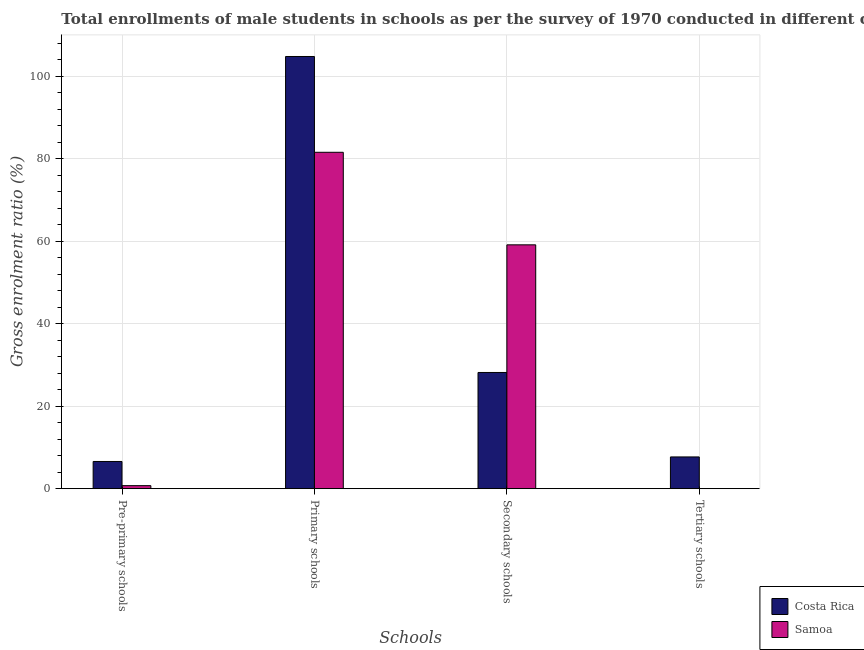How many different coloured bars are there?
Your answer should be compact. 2. How many groups of bars are there?
Your answer should be very brief. 4. Are the number of bars per tick equal to the number of legend labels?
Your response must be concise. Yes. Are the number of bars on each tick of the X-axis equal?
Your answer should be very brief. Yes. What is the label of the 3rd group of bars from the left?
Provide a succinct answer. Secondary schools. What is the gross enrolment ratio(male) in tertiary schools in Samoa?
Ensure brevity in your answer.  0.02. Across all countries, what is the maximum gross enrolment ratio(male) in pre-primary schools?
Ensure brevity in your answer.  6.6. Across all countries, what is the minimum gross enrolment ratio(male) in primary schools?
Keep it short and to the point. 81.57. In which country was the gross enrolment ratio(male) in secondary schools maximum?
Make the answer very short. Samoa. What is the total gross enrolment ratio(male) in pre-primary schools in the graph?
Provide a short and direct response. 7.33. What is the difference between the gross enrolment ratio(male) in tertiary schools in Samoa and that in Costa Rica?
Offer a terse response. -7.68. What is the difference between the gross enrolment ratio(male) in primary schools in Samoa and the gross enrolment ratio(male) in secondary schools in Costa Rica?
Your answer should be very brief. 53.39. What is the average gross enrolment ratio(male) in secondary schools per country?
Make the answer very short. 43.65. What is the difference between the gross enrolment ratio(male) in secondary schools and gross enrolment ratio(male) in primary schools in Samoa?
Make the answer very short. -22.44. In how many countries, is the gross enrolment ratio(male) in primary schools greater than 12 %?
Keep it short and to the point. 2. What is the ratio of the gross enrolment ratio(male) in pre-primary schools in Costa Rica to that in Samoa?
Provide a short and direct response. 8.98. Is the difference between the gross enrolment ratio(male) in primary schools in Costa Rica and Samoa greater than the difference between the gross enrolment ratio(male) in secondary schools in Costa Rica and Samoa?
Offer a terse response. Yes. What is the difference between the highest and the second highest gross enrolment ratio(male) in primary schools?
Keep it short and to the point. 23.23. What is the difference between the highest and the lowest gross enrolment ratio(male) in primary schools?
Your answer should be very brief. 23.23. In how many countries, is the gross enrolment ratio(male) in primary schools greater than the average gross enrolment ratio(male) in primary schools taken over all countries?
Offer a terse response. 1. Is the sum of the gross enrolment ratio(male) in tertiary schools in Samoa and Costa Rica greater than the maximum gross enrolment ratio(male) in secondary schools across all countries?
Provide a succinct answer. No. What does the 1st bar from the right in Tertiary schools represents?
Offer a terse response. Samoa. Are all the bars in the graph horizontal?
Ensure brevity in your answer.  No. What is the difference between two consecutive major ticks on the Y-axis?
Ensure brevity in your answer.  20. Does the graph contain any zero values?
Keep it short and to the point. No. Where does the legend appear in the graph?
Provide a short and direct response. Bottom right. How many legend labels are there?
Offer a very short reply. 2. What is the title of the graph?
Provide a succinct answer. Total enrollments of male students in schools as per the survey of 1970 conducted in different countries. What is the label or title of the X-axis?
Ensure brevity in your answer.  Schools. What is the label or title of the Y-axis?
Offer a terse response. Gross enrolment ratio (%). What is the Gross enrolment ratio (%) of Costa Rica in Pre-primary schools?
Give a very brief answer. 6.6. What is the Gross enrolment ratio (%) in Samoa in Pre-primary schools?
Give a very brief answer. 0.73. What is the Gross enrolment ratio (%) of Costa Rica in Primary schools?
Your response must be concise. 104.8. What is the Gross enrolment ratio (%) in Samoa in Primary schools?
Provide a short and direct response. 81.57. What is the Gross enrolment ratio (%) in Costa Rica in Secondary schools?
Keep it short and to the point. 28.18. What is the Gross enrolment ratio (%) in Samoa in Secondary schools?
Make the answer very short. 59.13. What is the Gross enrolment ratio (%) of Costa Rica in Tertiary schools?
Make the answer very short. 7.7. What is the Gross enrolment ratio (%) in Samoa in Tertiary schools?
Your answer should be compact. 0.02. Across all Schools, what is the maximum Gross enrolment ratio (%) in Costa Rica?
Your answer should be very brief. 104.8. Across all Schools, what is the maximum Gross enrolment ratio (%) of Samoa?
Offer a terse response. 81.57. Across all Schools, what is the minimum Gross enrolment ratio (%) in Costa Rica?
Provide a succinct answer. 6.6. Across all Schools, what is the minimum Gross enrolment ratio (%) of Samoa?
Offer a very short reply. 0.02. What is the total Gross enrolment ratio (%) in Costa Rica in the graph?
Make the answer very short. 147.28. What is the total Gross enrolment ratio (%) of Samoa in the graph?
Provide a succinct answer. 141.45. What is the difference between the Gross enrolment ratio (%) in Costa Rica in Pre-primary schools and that in Primary schools?
Keep it short and to the point. -98.21. What is the difference between the Gross enrolment ratio (%) of Samoa in Pre-primary schools and that in Primary schools?
Your answer should be very brief. -80.84. What is the difference between the Gross enrolment ratio (%) of Costa Rica in Pre-primary schools and that in Secondary schools?
Provide a short and direct response. -21.58. What is the difference between the Gross enrolment ratio (%) of Samoa in Pre-primary schools and that in Secondary schools?
Offer a very short reply. -58.4. What is the difference between the Gross enrolment ratio (%) of Costa Rica in Pre-primary schools and that in Tertiary schools?
Your answer should be very brief. -1.1. What is the difference between the Gross enrolment ratio (%) in Samoa in Pre-primary schools and that in Tertiary schools?
Make the answer very short. 0.72. What is the difference between the Gross enrolment ratio (%) of Costa Rica in Primary schools and that in Secondary schools?
Provide a short and direct response. 76.63. What is the difference between the Gross enrolment ratio (%) of Samoa in Primary schools and that in Secondary schools?
Provide a succinct answer. 22.44. What is the difference between the Gross enrolment ratio (%) in Costa Rica in Primary schools and that in Tertiary schools?
Offer a very short reply. 97.11. What is the difference between the Gross enrolment ratio (%) of Samoa in Primary schools and that in Tertiary schools?
Provide a succinct answer. 81.56. What is the difference between the Gross enrolment ratio (%) in Costa Rica in Secondary schools and that in Tertiary schools?
Make the answer very short. 20.48. What is the difference between the Gross enrolment ratio (%) in Samoa in Secondary schools and that in Tertiary schools?
Your response must be concise. 59.11. What is the difference between the Gross enrolment ratio (%) in Costa Rica in Pre-primary schools and the Gross enrolment ratio (%) in Samoa in Primary schools?
Ensure brevity in your answer.  -74.98. What is the difference between the Gross enrolment ratio (%) in Costa Rica in Pre-primary schools and the Gross enrolment ratio (%) in Samoa in Secondary schools?
Your answer should be compact. -52.54. What is the difference between the Gross enrolment ratio (%) in Costa Rica in Pre-primary schools and the Gross enrolment ratio (%) in Samoa in Tertiary schools?
Offer a terse response. 6.58. What is the difference between the Gross enrolment ratio (%) in Costa Rica in Primary schools and the Gross enrolment ratio (%) in Samoa in Secondary schools?
Offer a terse response. 45.67. What is the difference between the Gross enrolment ratio (%) of Costa Rica in Primary schools and the Gross enrolment ratio (%) of Samoa in Tertiary schools?
Provide a short and direct response. 104.79. What is the difference between the Gross enrolment ratio (%) of Costa Rica in Secondary schools and the Gross enrolment ratio (%) of Samoa in Tertiary schools?
Ensure brevity in your answer.  28.16. What is the average Gross enrolment ratio (%) in Costa Rica per Schools?
Ensure brevity in your answer.  36.82. What is the average Gross enrolment ratio (%) in Samoa per Schools?
Ensure brevity in your answer.  35.36. What is the difference between the Gross enrolment ratio (%) of Costa Rica and Gross enrolment ratio (%) of Samoa in Pre-primary schools?
Offer a terse response. 5.86. What is the difference between the Gross enrolment ratio (%) of Costa Rica and Gross enrolment ratio (%) of Samoa in Primary schools?
Keep it short and to the point. 23.23. What is the difference between the Gross enrolment ratio (%) in Costa Rica and Gross enrolment ratio (%) in Samoa in Secondary schools?
Keep it short and to the point. -30.95. What is the difference between the Gross enrolment ratio (%) of Costa Rica and Gross enrolment ratio (%) of Samoa in Tertiary schools?
Keep it short and to the point. 7.68. What is the ratio of the Gross enrolment ratio (%) of Costa Rica in Pre-primary schools to that in Primary schools?
Give a very brief answer. 0.06. What is the ratio of the Gross enrolment ratio (%) in Samoa in Pre-primary schools to that in Primary schools?
Provide a succinct answer. 0.01. What is the ratio of the Gross enrolment ratio (%) in Costa Rica in Pre-primary schools to that in Secondary schools?
Your answer should be very brief. 0.23. What is the ratio of the Gross enrolment ratio (%) of Samoa in Pre-primary schools to that in Secondary schools?
Your response must be concise. 0.01. What is the ratio of the Gross enrolment ratio (%) in Costa Rica in Pre-primary schools to that in Tertiary schools?
Ensure brevity in your answer.  0.86. What is the ratio of the Gross enrolment ratio (%) of Samoa in Pre-primary schools to that in Tertiary schools?
Make the answer very short. 42.93. What is the ratio of the Gross enrolment ratio (%) in Costa Rica in Primary schools to that in Secondary schools?
Keep it short and to the point. 3.72. What is the ratio of the Gross enrolment ratio (%) in Samoa in Primary schools to that in Secondary schools?
Give a very brief answer. 1.38. What is the ratio of the Gross enrolment ratio (%) of Costa Rica in Primary schools to that in Tertiary schools?
Your answer should be compact. 13.61. What is the ratio of the Gross enrolment ratio (%) in Samoa in Primary schools to that in Tertiary schools?
Your response must be concise. 4770.37. What is the ratio of the Gross enrolment ratio (%) of Costa Rica in Secondary schools to that in Tertiary schools?
Provide a succinct answer. 3.66. What is the ratio of the Gross enrolment ratio (%) of Samoa in Secondary schools to that in Tertiary schools?
Provide a short and direct response. 3457.91. What is the difference between the highest and the second highest Gross enrolment ratio (%) in Costa Rica?
Provide a short and direct response. 76.63. What is the difference between the highest and the second highest Gross enrolment ratio (%) of Samoa?
Provide a succinct answer. 22.44. What is the difference between the highest and the lowest Gross enrolment ratio (%) in Costa Rica?
Make the answer very short. 98.21. What is the difference between the highest and the lowest Gross enrolment ratio (%) of Samoa?
Your answer should be compact. 81.56. 